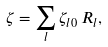<formula> <loc_0><loc_0><loc_500><loc_500>\zeta = \sum _ { l } \zeta _ { l 0 } \, R _ { l } ,</formula> 